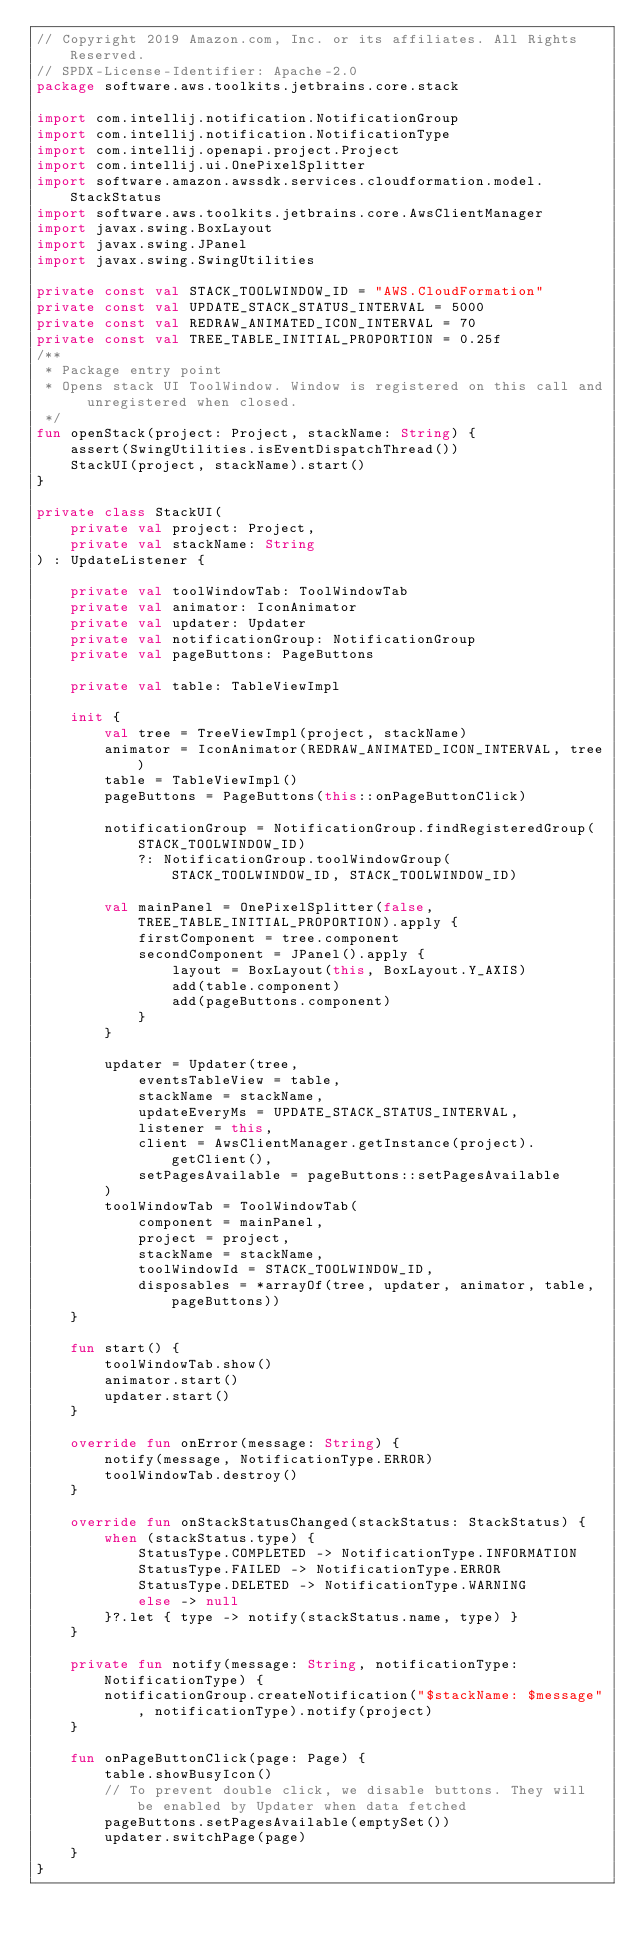<code> <loc_0><loc_0><loc_500><loc_500><_Kotlin_>// Copyright 2019 Amazon.com, Inc. or its affiliates. All Rights Reserved.
// SPDX-License-Identifier: Apache-2.0
package software.aws.toolkits.jetbrains.core.stack

import com.intellij.notification.NotificationGroup
import com.intellij.notification.NotificationType
import com.intellij.openapi.project.Project
import com.intellij.ui.OnePixelSplitter
import software.amazon.awssdk.services.cloudformation.model.StackStatus
import software.aws.toolkits.jetbrains.core.AwsClientManager
import javax.swing.BoxLayout
import javax.swing.JPanel
import javax.swing.SwingUtilities

private const val STACK_TOOLWINDOW_ID = "AWS.CloudFormation"
private const val UPDATE_STACK_STATUS_INTERVAL = 5000
private const val REDRAW_ANIMATED_ICON_INTERVAL = 70
private const val TREE_TABLE_INITIAL_PROPORTION = 0.25f
/**
 * Package entry point
 * Opens stack UI ToolWindow. Window is registered on this call and unregistered when closed.
 */
fun openStack(project: Project, stackName: String) {
    assert(SwingUtilities.isEventDispatchThread())
    StackUI(project, stackName).start()
}

private class StackUI(
    private val project: Project,
    private val stackName: String
) : UpdateListener {

    private val toolWindowTab: ToolWindowTab
    private val animator: IconAnimator
    private val updater: Updater
    private val notificationGroup: NotificationGroup
    private val pageButtons: PageButtons

    private val table: TableViewImpl

    init {
        val tree = TreeViewImpl(project, stackName)
        animator = IconAnimator(REDRAW_ANIMATED_ICON_INTERVAL, tree)
        table = TableViewImpl()
        pageButtons = PageButtons(this::onPageButtonClick)

        notificationGroup = NotificationGroup.findRegisteredGroup(STACK_TOOLWINDOW_ID)
            ?: NotificationGroup.toolWindowGroup(STACK_TOOLWINDOW_ID, STACK_TOOLWINDOW_ID)

        val mainPanel = OnePixelSplitter(false, TREE_TABLE_INITIAL_PROPORTION).apply {
            firstComponent = tree.component
            secondComponent = JPanel().apply {
                layout = BoxLayout(this, BoxLayout.Y_AXIS)
                add(table.component)
                add(pageButtons.component)
            }
        }

        updater = Updater(tree,
            eventsTableView = table,
            stackName = stackName,
            updateEveryMs = UPDATE_STACK_STATUS_INTERVAL,
            listener = this,
            client = AwsClientManager.getInstance(project).getClient(),
            setPagesAvailable = pageButtons::setPagesAvailable
        )
        toolWindowTab = ToolWindowTab(
            component = mainPanel,
            project = project,
            stackName = stackName,
            toolWindowId = STACK_TOOLWINDOW_ID,
            disposables = *arrayOf(tree, updater, animator, table, pageButtons))
    }

    fun start() {
        toolWindowTab.show()
        animator.start()
        updater.start()
    }

    override fun onError(message: String) {
        notify(message, NotificationType.ERROR)
        toolWindowTab.destroy()
    }

    override fun onStackStatusChanged(stackStatus: StackStatus) {
        when (stackStatus.type) {
            StatusType.COMPLETED -> NotificationType.INFORMATION
            StatusType.FAILED -> NotificationType.ERROR
            StatusType.DELETED -> NotificationType.WARNING
            else -> null
        }?.let { type -> notify(stackStatus.name, type) }
    }

    private fun notify(message: String, notificationType: NotificationType) {
        notificationGroup.createNotification("$stackName: $message", notificationType).notify(project)
    }

    fun onPageButtonClick(page: Page) {
        table.showBusyIcon()
        // To prevent double click, we disable buttons. They will be enabled by Updater when data fetched
        pageButtons.setPagesAvailable(emptySet())
        updater.switchPage(page)
    }
}
</code> 